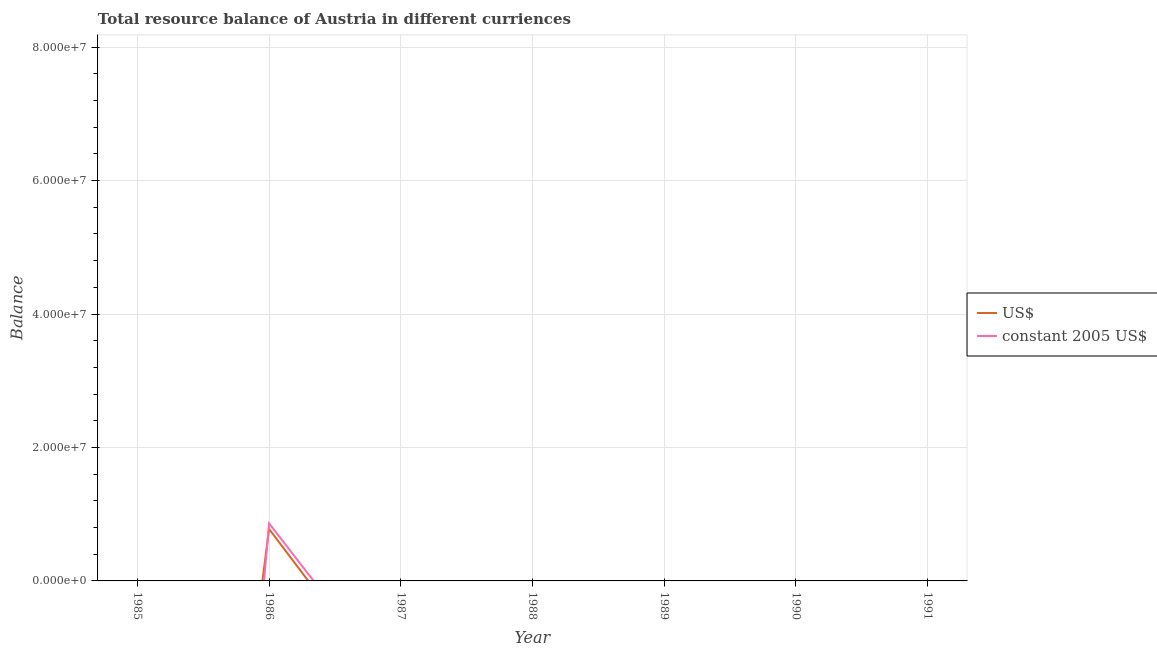Does the line corresponding to resource balance in us$ intersect with the line corresponding to resource balance in constant us$?
Give a very brief answer. Yes. Is the number of lines equal to the number of legend labels?
Provide a short and direct response. No. What is the resource balance in us$ in 1991?
Keep it short and to the point. 0. Across all years, what is the maximum resource balance in us$?
Ensure brevity in your answer.  7.78e+06. Across all years, what is the minimum resource balance in us$?
Your answer should be compact. 0. What is the total resource balance in constant us$ in the graph?
Provide a short and direct response. 8.64e+06. What is the difference between the resource balance in us$ in 1989 and the resource balance in constant us$ in 1988?
Offer a very short reply. 0. What is the average resource balance in us$ per year?
Offer a terse response. 1.11e+06. In the year 1986, what is the difference between the resource balance in us$ and resource balance in constant us$?
Your answer should be compact. -8.52e+05. In how many years, is the resource balance in constant us$ greater than 16000000 units?
Your response must be concise. 0. What is the difference between the highest and the lowest resource balance in us$?
Make the answer very short. 7.78e+06. Does the resource balance in constant us$ monotonically increase over the years?
Keep it short and to the point. No. Are the values on the major ticks of Y-axis written in scientific E-notation?
Provide a succinct answer. Yes. Does the graph contain grids?
Your answer should be compact. Yes. What is the title of the graph?
Make the answer very short. Total resource balance of Austria in different curriences. What is the label or title of the Y-axis?
Keep it short and to the point. Balance. What is the Balance in US$ in 1985?
Your answer should be very brief. 0. What is the Balance in US$ in 1986?
Your answer should be compact. 7.78e+06. What is the Balance of constant 2005 US$ in 1986?
Your answer should be compact. 8.64e+06. What is the Balance in US$ in 1987?
Offer a very short reply. 0. What is the Balance in US$ in 1988?
Your answer should be very brief. 0. What is the Balance in US$ in 1991?
Offer a very short reply. 0. What is the Balance in constant 2005 US$ in 1991?
Make the answer very short. 0. Across all years, what is the maximum Balance of US$?
Give a very brief answer. 7.78e+06. Across all years, what is the maximum Balance in constant 2005 US$?
Your answer should be very brief. 8.64e+06. What is the total Balance of US$ in the graph?
Your answer should be compact. 7.78e+06. What is the total Balance in constant 2005 US$ in the graph?
Your response must be concise. 8.64e+06. What is the average Balance of US$ per year?
Offer a terse response. 1.11e+06. What is the average Balance in constant 2005 US$ per year?
Provide a succinct answer. 1.23e+06. In the year 1986, what is the difference between the Balance of US$ and Balance of constant 2005 US$?
Offer a very short reply. -8.52e+05. What is the difference between the highest and the lowest Balance in US$?
Make the answer very short. 7.78e+06. What is the difference between the highest and the lowest Balance in constant 2005 US$?
Provide a succinct answer. 8.64e+06. 